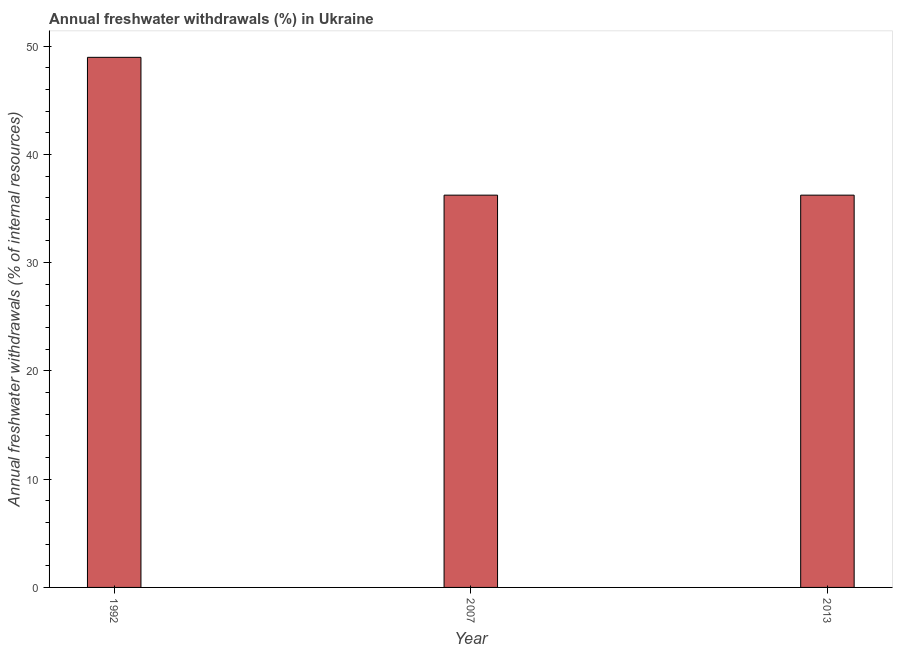Does the graph contain any zero values?
Ensure brevity in your answer.  No. Does the graph contain grids?
Your response must be concise. No. What is the title of the graph?
Provide a succinct answer. Annual freshwater withdrawals (%) in Ukraine. What is the label or title of the X-axis?
Keep it short and to the point. Year. What is the label or title of the Y-axis?
Give a very brief answer. Annual freshwater withdrawals (% of internal resources). What is the annual freshwater withdrawals in 1992?
Offer a terse response. 48.96. Across all years, what is the maximum annual freshwater withdrawals?
Keep it short and to the point. 48.96. Across all years, what is the minimum annual freshwater withdrawals?
Offer a very short reply. 36.23. In which year was the annual freshwater withdrawals maximum?
Offer a terse response. 1992. In which year was the annual freshwater withdrawals minimum?
Offer a terse response. 2007. What is the sum of the annual freshwater withdrawals?
Offer a very short reply. 121.43. What is the average annual freshwater withdrawals per year?
Give a very brief answer. 40.48. What is the median annual freshwater withdrawals?
Your answer should be compact. 36.23. In how many years, is the annual freshwater withdrawals greater than 10 %?
Provide a succinct answer. 3. What is the ratio of the annual freshwater withdrawals in 1992 to that in 2013?
Your response must be concise. 1.35. Is the annual freshwater withdrawals in 1992 less than that in 2013?
Your answer should be very brief. No. What is the difference between the highest and the second highest annual freshwater withdrawals?
Your response must be concise. 12.73. What is the difference between the highest and the lowest annual freshwater withdrawals?
Your answer should be very brief. 12.73. In how many years, is the annual freshwater withdrawals greater than the average annual freshwater withdrawals taken over all years?
Offer a terse response. 1. Are all the bars in the graph horizontal?
Your response must be concise. No. How many years are there in the graph?
Your answer should be compact. 3. What is the difference between two consecutive major ticks on the Y-axis?
Make the answer very short. 10. Are the values on the major ticks of Y-axis written in scientific E-notation?
Make the answer very short. No. What is the Annual freshwater withdrawals (% of internal resources) of 1992?
Provide a succinct answer. 48.96. What is the Annual freshwater withdrawals (% of internal resources) in 2007?
Ensure brevity in your answer.  36.23. What is the Annual freshwater withdrawals (% of internal resources) in 2013?
Your answer should be very brief. 36.23. What is the difference between the Annual freshwater withdrawals (% of internal resources) in 1992 and 2007?
Offer a terse response. 12.73. What is the difference between the Annual freshwater withdrawals (% of internal resources) in 1992 and 2013?
Make the answer very short. 12.73. What is the ratio of the Annual freshwater withdrawals (% of internal resources) in 1992 to that in 2007?
Offer a very short reply. 1.35. What is the ratio of the Annual freshwater withdrawals (% of internal resources) in 1992 to that in 2013?
Offer a very short reply. 1.35. 